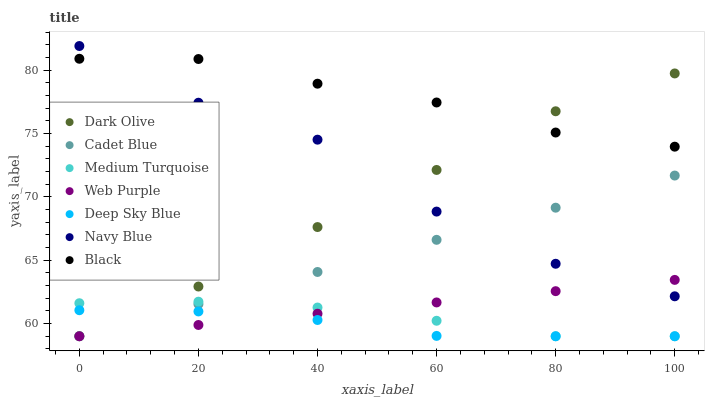Does Deep Sky Blue have the minimum area under the curve?
Answer yes or no. Yes. Does Black have the maximum area under the curve?
Answer yes or no. Yes. Does Medium Turquoise have the minimum area under the curve?
Answer yes or no. No. Does Medium Turquoise have the maximum area under the curve?
Answer yes or no. No. Is Web Purple the smoothest?
Answer yes or no. Yes. Is Navy Blue the roughest?
Answer yes or no. Yes. Is Medium Turquoise the smoothest?
Answer yes or no. No. Is Medium Turquoise the roughest?
Answer yes or no. No. Does Cadet Blue have the lowest value?
Answer yes or no. Yes. Does Navy Blue have the lowest value?
Answer yes or no. No. Does Navy Blue have the highest value?
Answer yes or no. Yes. Does Medium Turquoise have the highest value?
Answer yes or no. No. Is Cadet Blue less than Dark Olive?
Answer yes or no. Yes. Is Navy Blue greater than Medium Turquoise?
Answer yes or no. Yes. Does Cadet Blue intersect Navy Blue?
Answer yes or no. Yes. Is Cadet Blue less than Navy Blue?
Answer yes or no. No. Is Cadet Blue greater than Navy Blue?
Answer yes or no. No. Does Cadet Blue intersect Dark Olive?
Answer yes or no. No. 